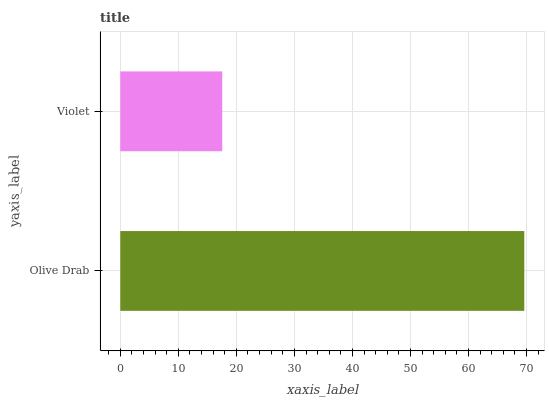Is Violet the minimum?
Answer yes or no. Yes. Is Olive Drab the maximum?
Answer yes or no. Yes. Is Violet the maximum?
Answer yes or no. No. Is Olive Drab greater than Violet?
Answer yes or no. Yes. Is Violet less than Olive Drab?
Answer yes or no. Yes. Is Violet greater than Olive Drab?
Answer yes or no. No. Is Olive Drab less than Violet?
Answer yes or no. No. Is Olive Drab the high median?
Answer yes or no. Yes. Is Violet the low median?
Answer yes or no. Yes. Is Violet the high median?
Answer yes or no. No. Is Olive Drab the low median?
Answer yes or no. No. 